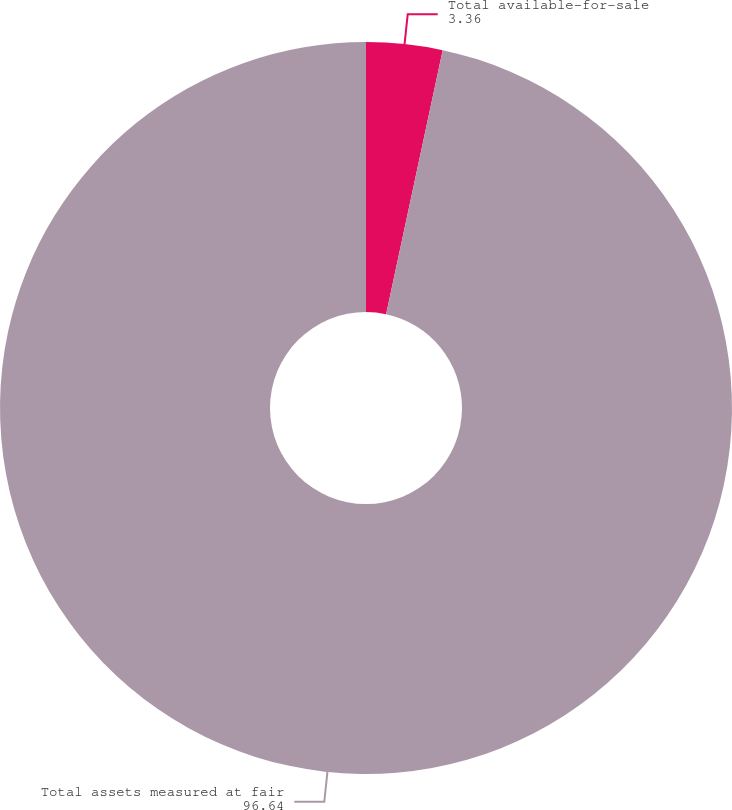Convert chart. <chart><loc_0><loc_0><loc_500><loc_500><pie_chart><fcel>Total available-for-sale<fcel>Total assets measured at fair<nl><fcel>3.36%<fcel>96.64%<nl></chart> 